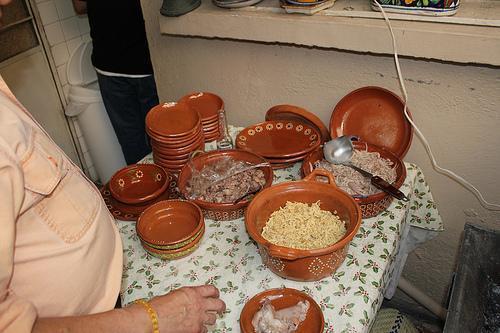How many dishes have food in them?
Give a very brief answer. 4. 